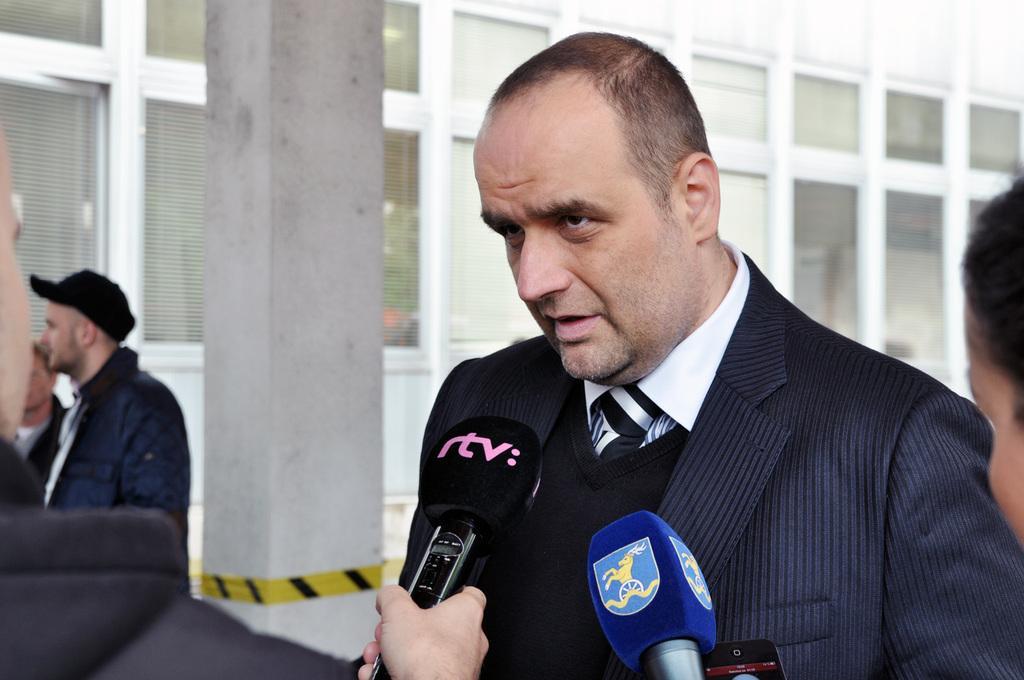Please provide a concise description of this image. In this picture there is a person standing and talking and in the foreground there are two persons standing and holding the microphones. On the left side of the image there are two persons standing. At the back there is a building and there are lights inside the building. At the back there is a pillar and there is a yellow sticker on the pillar. 